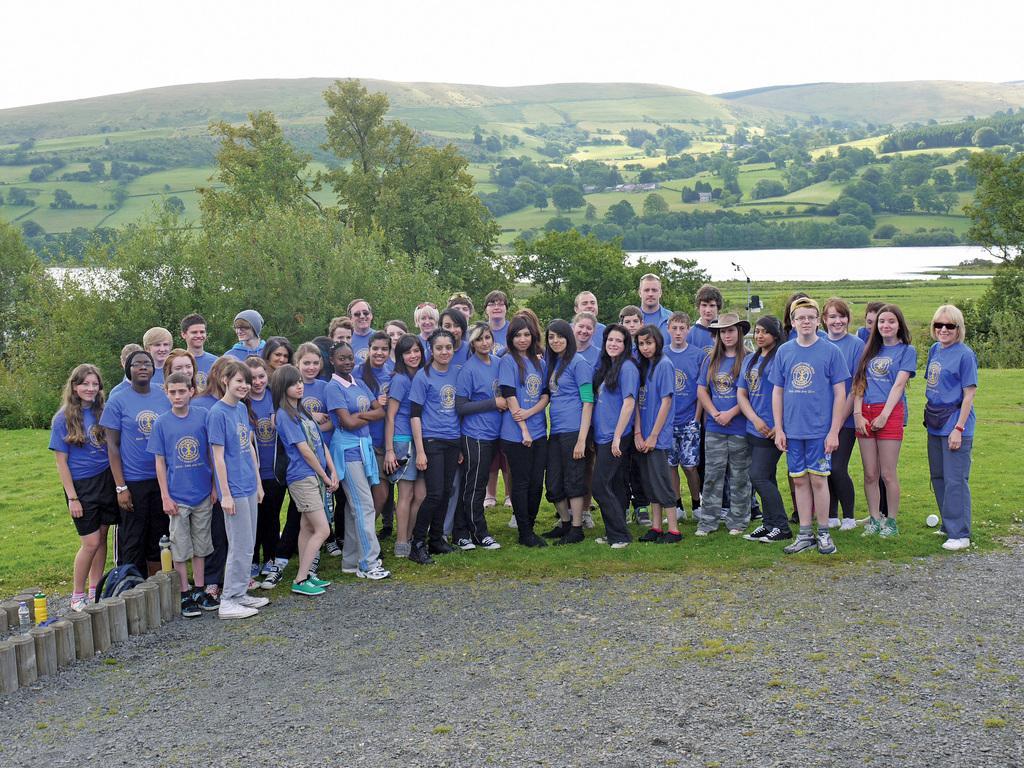Describe this image in one or two sentences. In this picture I can see there are group of people standing and wearing blue t-shirts. In the backdrop there are trees and mountains and the sky is clear. 